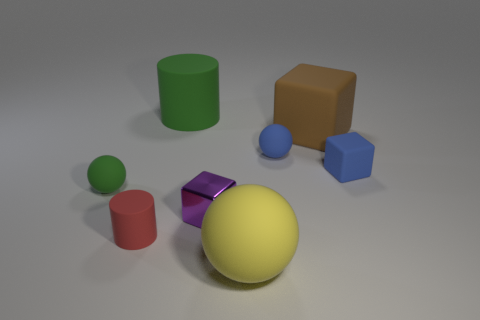Subtract all rubber blocks. How many blocks are left? 1 Add 1 tiny cyan rubber blocks. How many objects exist? 9 Subtract all red cylinders. How many cylinders are left? 1 Subtract all balls. How many objects are left? 5 Subtract 3 balls. How many balls are left? 0 Subtract all blue cylinders. Subtract all purple blocks. How many cylinders are left? 2 Add 7 green rubber balls. How many green rubber balls are left? 8 Add 3 small matte cylinders. How many small matte cylinders exist? 4 Subtract 1 red cylinders. How many objects are left? 7 Subtract all purple cubes. How many purple cylinders are left? 0 